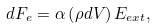Convert formula to latex. <formula><loc_0><loc_0><loc_500><loc_500>d { F } _ { e } = \alpha \left ( \rho d V \right ) { E } _ { e x t } ,</formula> 